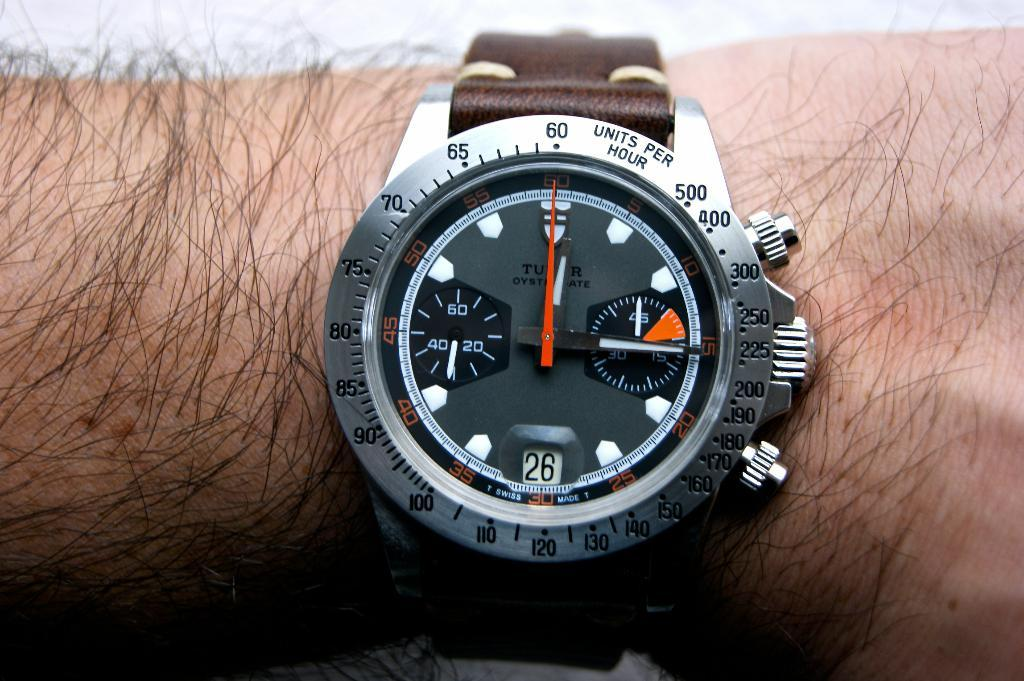<image>
Relay a brief, clear account of the picture shown. A watch on a man's wrist has a units per hour scale around the rim. 